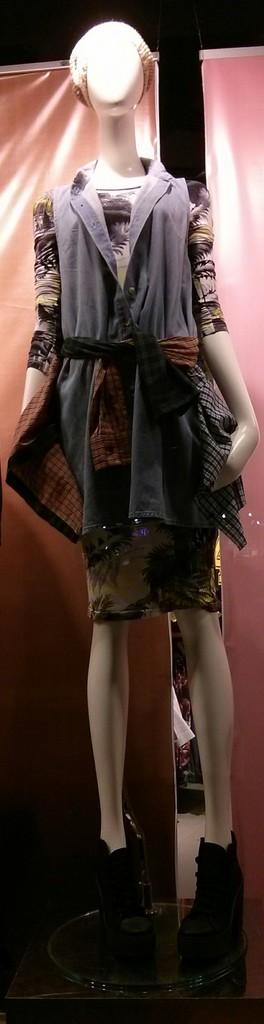What is the main subject of the image? There is a mannequin in the image. What is the mannequin wearing? The mannequin is wearing a costume. Can you describe any additional details about the mannequin? There is a light shadow on the mannequin. How many geese are flying over the mannequin in the image? There are no geese present in the image. What type of coat is the mannequin wearing? The mannequin is not wearing a coat; it is wearing a costume. 